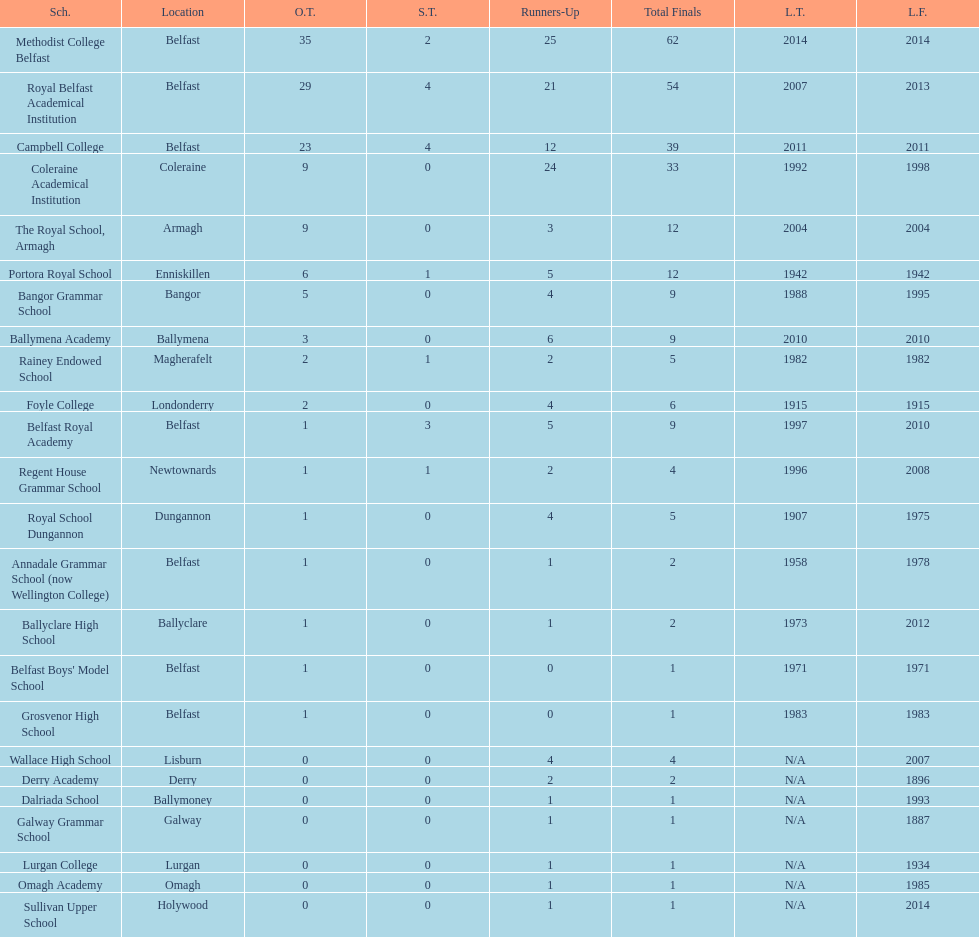What number of total finals does foyle college have? 6. 